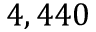<formula> <loc_0><loc_0><loc_500><loc_500>4 , 4 4 0</formula> 